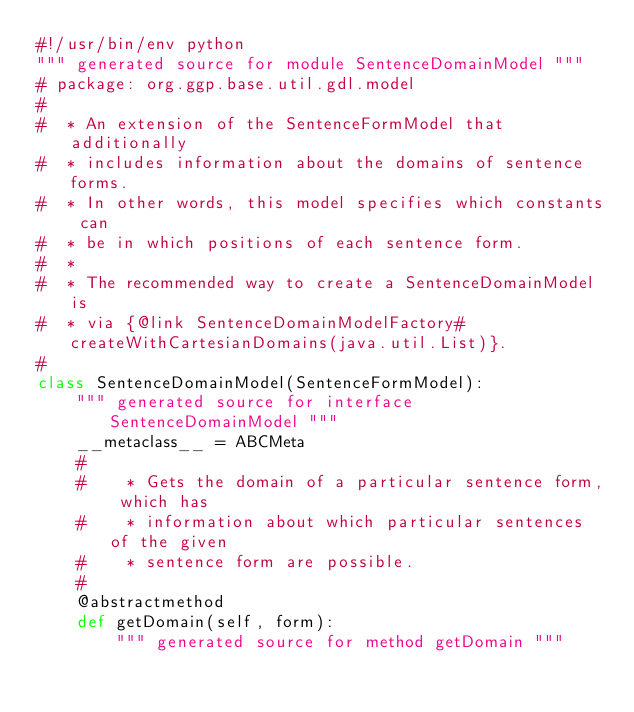<code> <loc_0><loc_0><loc_500><loc_500><_Python_>#!/usr/bin/env python
""" generated source for module SentenceDomainModel """
# package: org.ggp.base.util.gdl.model
# 
#  * An extension of the SentenceFormModel that additionally
#  * includes information about the domains of sentence forms.
#  * In other words, this model specifies which constants can
#  * be in which positions of each sentence form.
#  *
#  * The recommended way to create a SentenceDomainModel is
#  * via {@link SentenceDomainModelFactory#createWithCartesianDomains(java.util.List)}.
#  
class SentenceDomainModel(SentenceFormModel):
    """ generated source for interface SentenceDomainModel """
    __metaclass__ = ABCMeta
    # 
    # 	 * Gets the domain of a particular sentence form, which has
    # 	 * information about which particular sentences of the given
    # 	 * sentence form are possible.
    # 	 
    @abstractmethod
    def getDomain(self, form):
        """ generated source for method getDomain """

</code> 